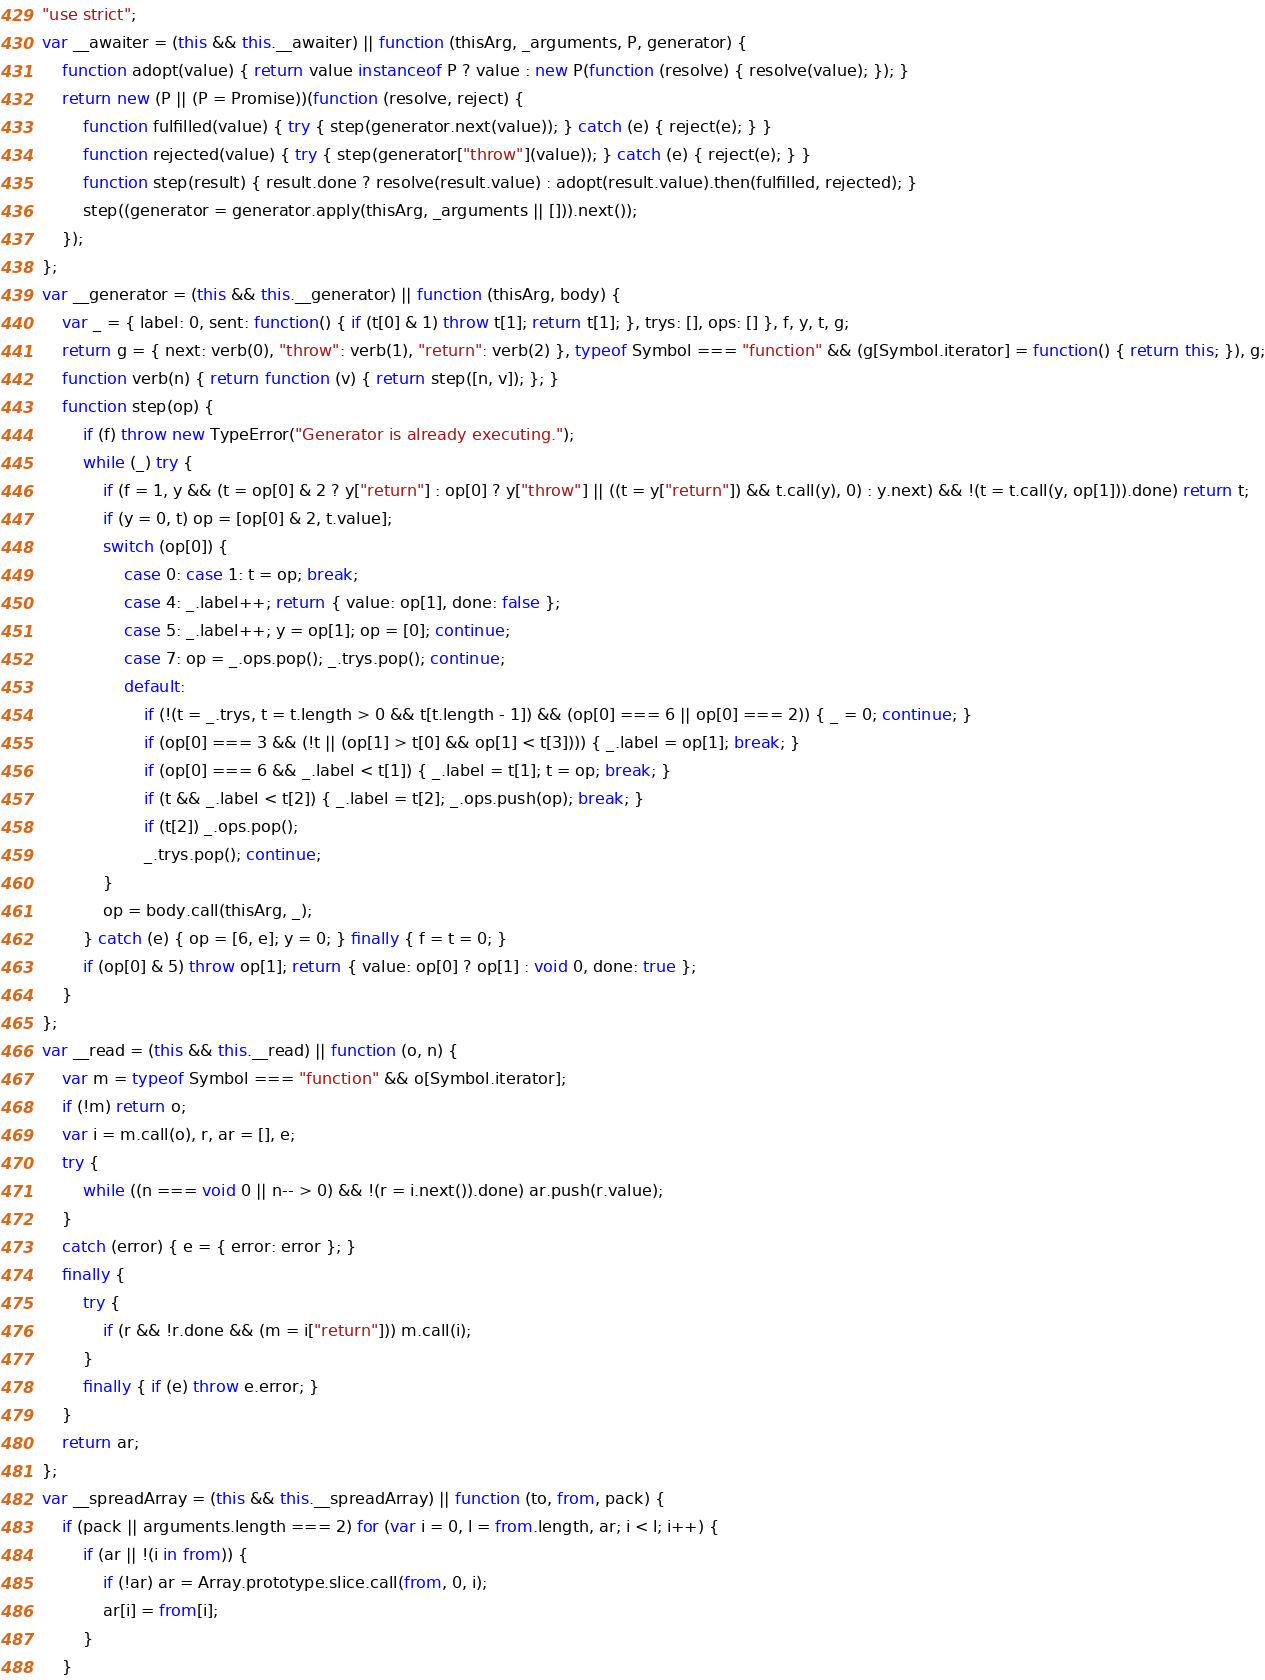Convert code to text. <code><loc_0><loc_0><loc_500><loc_500><_JavaScript_>"use strict";
var __awaiter = (this && this.__awaiter) || function (thisArg, _arguments, P, generator) {
    function adopt(value) { return value instanceof P ? value : new P(function (resolve) { resolve(value); }); }
    return new (P || (P = Promise))(function (resolve, reject) {
        function fulfilled(value) { try { step(generator.next(value)); } catch (e) { reject(e); } }
        function rejected(value) { try { step(generator["throw"](value)); } catch (e) { reject(e); } }
        function step(result) { result.done ? resolve(result.value) : adopt(result.value).then(fulfilled, rejected); }
        step((generator = generator.apply(thisArg, _arguments || [])).next());
    });
};
var __generator = (this && this.__generator) || function (thisArg, body) {
    var _ = { label: 0, sent: function() { if (t[0] & 1) throw t[1]; return t[1]; }, trys: [], ops: [] }, f, y, t, g;
    return g = { next: verb(0), "throw": verb(1), "return": verb(2) }, typeof Symbol === "function" && (g[Symbol.iterator] = function() { return this; }), g;
    function verb(n) { return function (v) { return step([n, v]); }; }
    function step(op) {
        if (f) throw new TypeError("Generator is already executing.");
        while (_) try {
            if (f = 1, y && (t = op[0] & 2 ? y["return"] : op[0] ? y["throw"] || ((t = y["return"]) && t.call(y), 0) : y.next) && !(t = t.call(y, op[1])).done) return t;
            if (y = 0, t) op = [op[0] & 2, t.value];
            switch (op[0]) {
                case 0: case 1: t = op; break;
                case 4: _.label++; return { value: op[1], done: false };
                case 5: _.label++; y = op[1]; op = [0]; continue;
                case 7: op = _.ops.pop(); _.trys.pop(); continue;
                default:
                    if (!(t = _.trys, t = t.length > 0 && t[t.length - 1]) && (op[0] === 6 || op[0] === 2)) { _ = 0; continue; }
                    if (op[0] === 3 && (!t || (op[1] > t[0] && op[1] < t[3]))) { _.label = op[1]; break; }
                    if (op[0] === 6 && _.label < t[1]) { _.label = t[1]; t = op; break; }
                    if (t && _.label < t[2]) { _.label = t[2]; _.ops.push(op); break; }
                    if (t[2]) _.ops.pop();
                    _.trys.pop(); continue;
            }
            op = body.call(thisArg, _);
        } catch (e) { op = [6, e]; y = 0; } finally { f = t = 0; }
        if (op[0] & 5) throw op[1]; return { value: op[0] ? op[1] : void 0, done: true };
    }
};
var __read = (this && this.__read) || function (o, n) {
    var m = typeof Symbol === "function" && o[Symbol.iterator];
    if (!m) return o;
    var i = m.call(o), r, ar = [], e;
    try {
        while ((n === void 0 || n-- > 0) && !(r = i.next()).done) ar.push(r.value);
    }
    catch (error) { e = { error: error }; }
    finally {
        try {
            if (r && !r.done && (m = i["return"])) m.call(i);
        }
        finally { if (e) throw e.error; }
    }
    return ar;
};
var __spreadArray = (this && this.__spreadArray) || function (to, from, pack) {
    if (pack || arguments.length === 2) for (var i = 0, l = from.length, ar; i < l; i++) {
        if (ar || !(i in from)) {
            if (!ar) ar = Array.prototype.slice.call(from, 0, i);
            ar[i] = from[i];
        }
    }</code> 